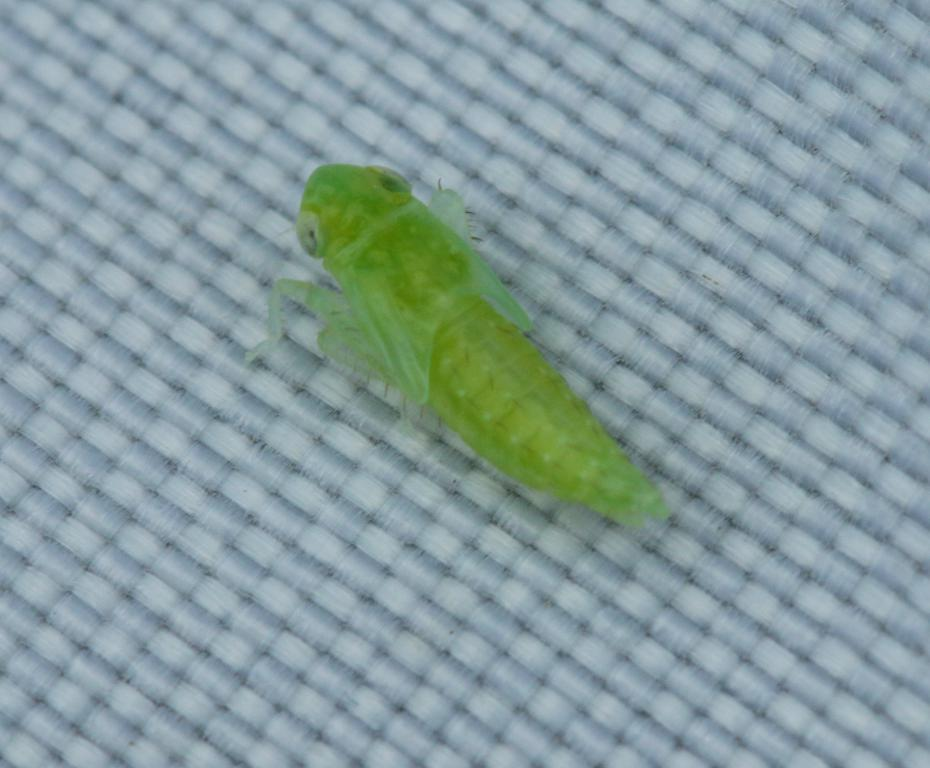What type of creature is present in the image? There is an insect in the image. Where is the insect located in the image? The insect is on a surface. What type of ink is used to draw the sail in the image? There is no sail present in the image, and therefore no ink can be associated with it. 